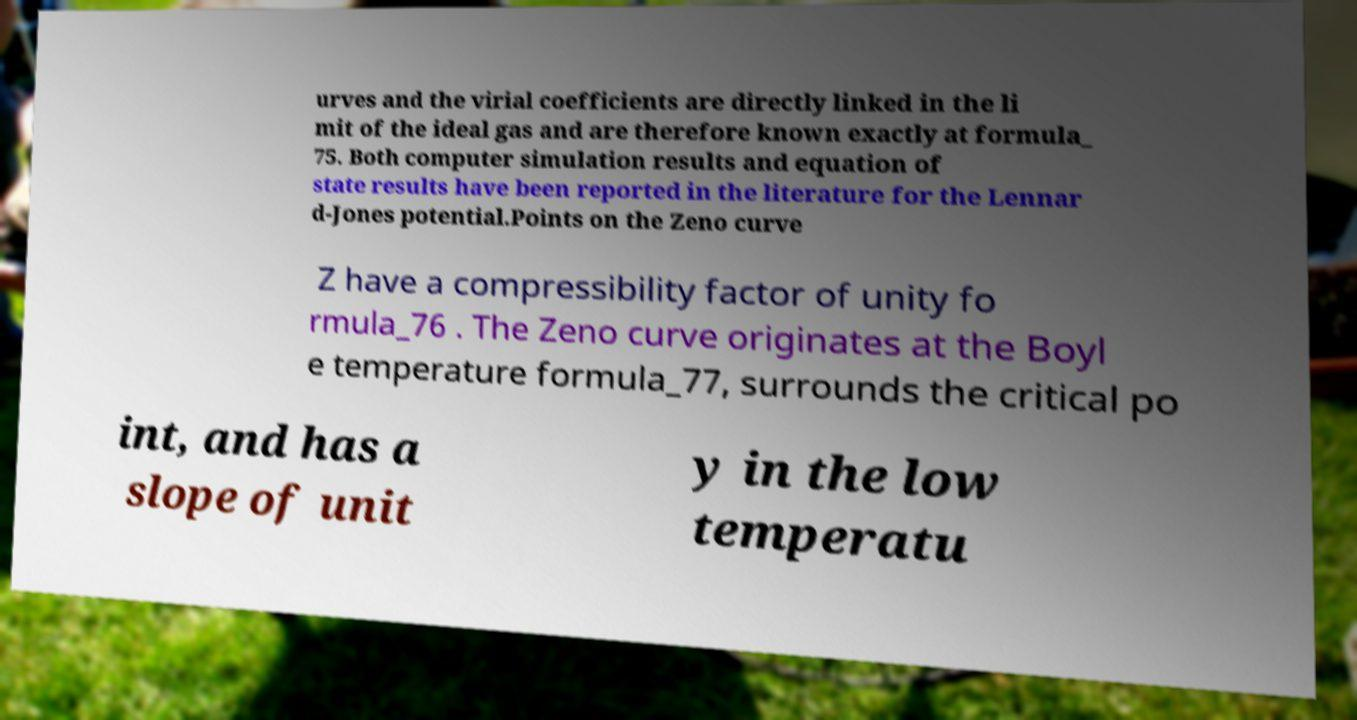What messages or text are displayed in this image? I need them in a readable, typed format. urves and the virial coefficients are directly linked in the li mit of the ideal gas and are therefore known exactly at formula_ 75. Both computer simulation results and equation of state results have been reported in the literature for the Lennar d-Jones potential.Points on the Zeno curve Z have a compressibility factor of unity fo rmula_76 . The Zeno curve originates at the Boyl e temperature formula_77, surrounds the critical po int, and has a slope of unit y in the low temperatu 